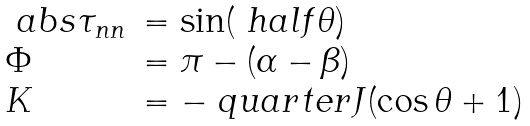<formula> <loc_0><loc_0><loc_500><loc_500>\begin{array} { l l } \ a b s { \tau _ { n n } } & = \sin ( \ h a l f \theta ) \\ \Phi & = \pi - ( \alpha - \beta ) \\ K & = - \ q u a r t e r J ( \cos \theta + 1 ) \end{array}</formula> 